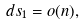Convert formula to latex. <formula><loc_0><loc_0><loc_500><loc_500>d s _ { 1 } = o ( n ) ,</formula> 